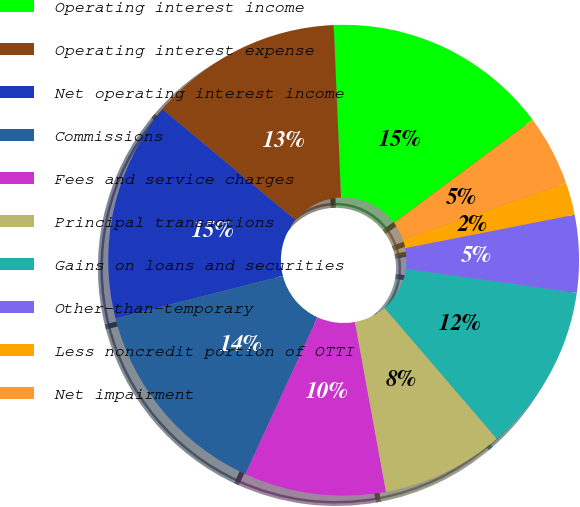<chart> <loc_0><loc_0><loc_500><loc_500><pie_chart><fcel>Operating interest income<fcel>Operating interest expense<fcel>Net operating interest income<fcel>Commissions<fcel>Fees and service charges<fcel>Principal transactions<fcel>Gains on loans and securities<fcel>Other-than-temporary<fcel>Less noncredit portion of OTTI<fcel>Net impairment<nl><fcel>15.49%<fcel>13.27%<fcel>15.04%<fcel>14.16%<fcel>9.73%<fcel>8.41%<fcel>11.5%<fcel>5.31%<fcel>2.21%<fcel>4.87%<nl></chart> 